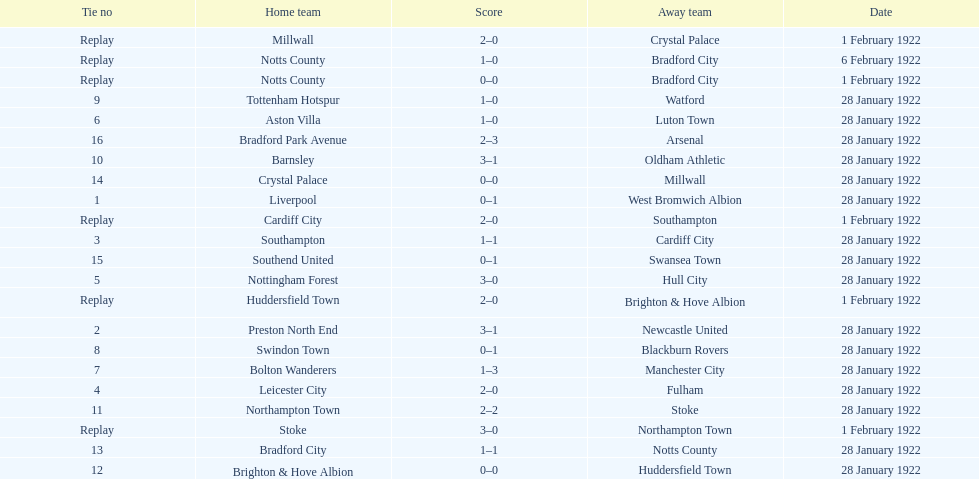How many games had four total points scored or more? 5. 